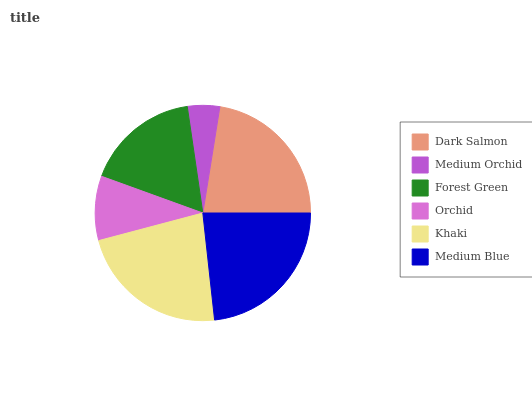Is Medium Orchid the minimum?
Answer yes or no. Yes. Is Medium Blue the maximum?
Answer yes or no. Yes. Is Forest Green the minimum?
Answer yes or no. No. Is Forest Green the maximum?
Answer yes or no. No. Is Forest Green greater than Medium Orchid?
Answer yes or no. Yes. Is Medium Orchid less than Forest Green?
Answer yes or no. Yes. Is Medium Orchid greater than Forest Green?
Answer yes or no. No. Is Forest Green less than Medium Orchid?
Answer yes or no. No. Is Dark Salmon the high median?
Answer yes or no. Yes. Is Forest Green the low median?
Answer yes or no. Yes. Is Medium Orchid the high median?
Answer yes or no. No. Is Dark Salmon the low median?
Answer yes or no. No. 